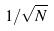Convert formula to latex. <formula><loc_0><loc_0><loc_500><loc_500>1 / \sqrt { N }</formula> 